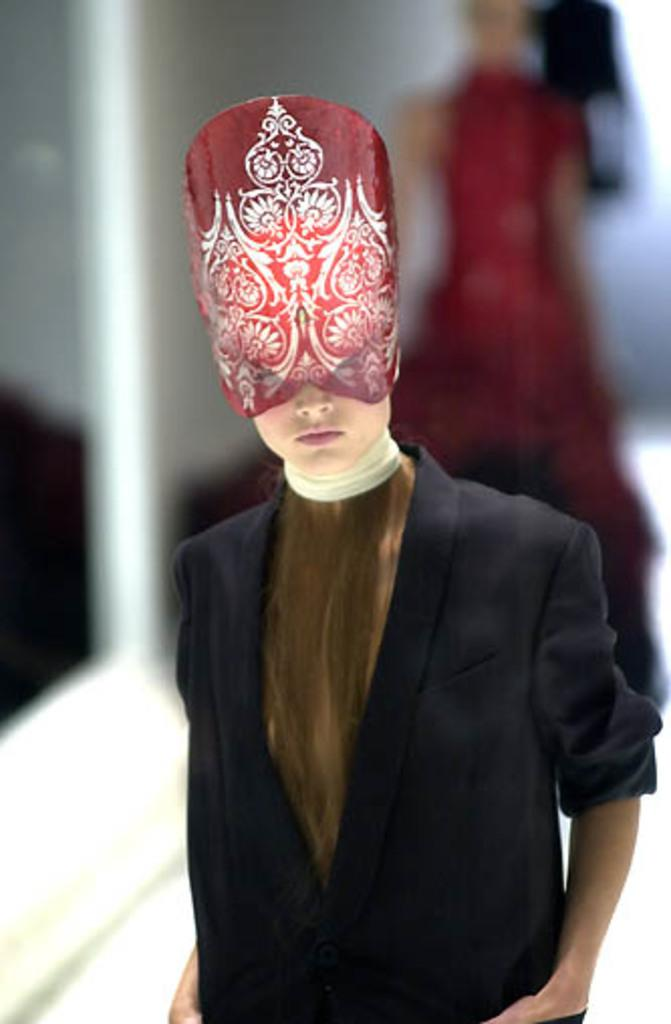What is the person in the image wearing? The person in the image is wearing a black and brown color dress and red and white colored headwear. Can you describe the headwear the person is wearing? The person is wearing red and white colored headwear. Is there anyone else visible in the image? Yes, there is a blurred person in the background of the image. What game is the person in the image thinking about? There is no indication in the image that the person is thinking about a game. 